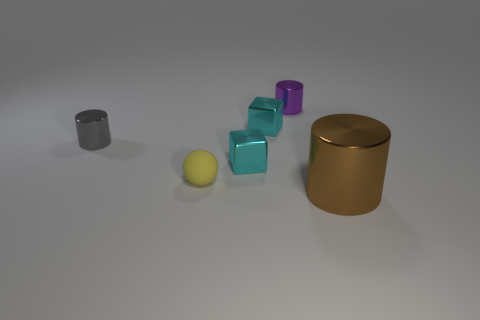Are there the same number of metal things that are on the left side of the tiny gray cylinder and tiny brown metallic objects? Yes, upon analyzing the image, there are two metallic objects situated on the left side of the small gray cylinder, which are, a silver-colored cylinder and a gold-toned cylinder. Similarly, there are two tiny brown metallic cubes, resulting in an equal number of metallic items when comparing both groups. 